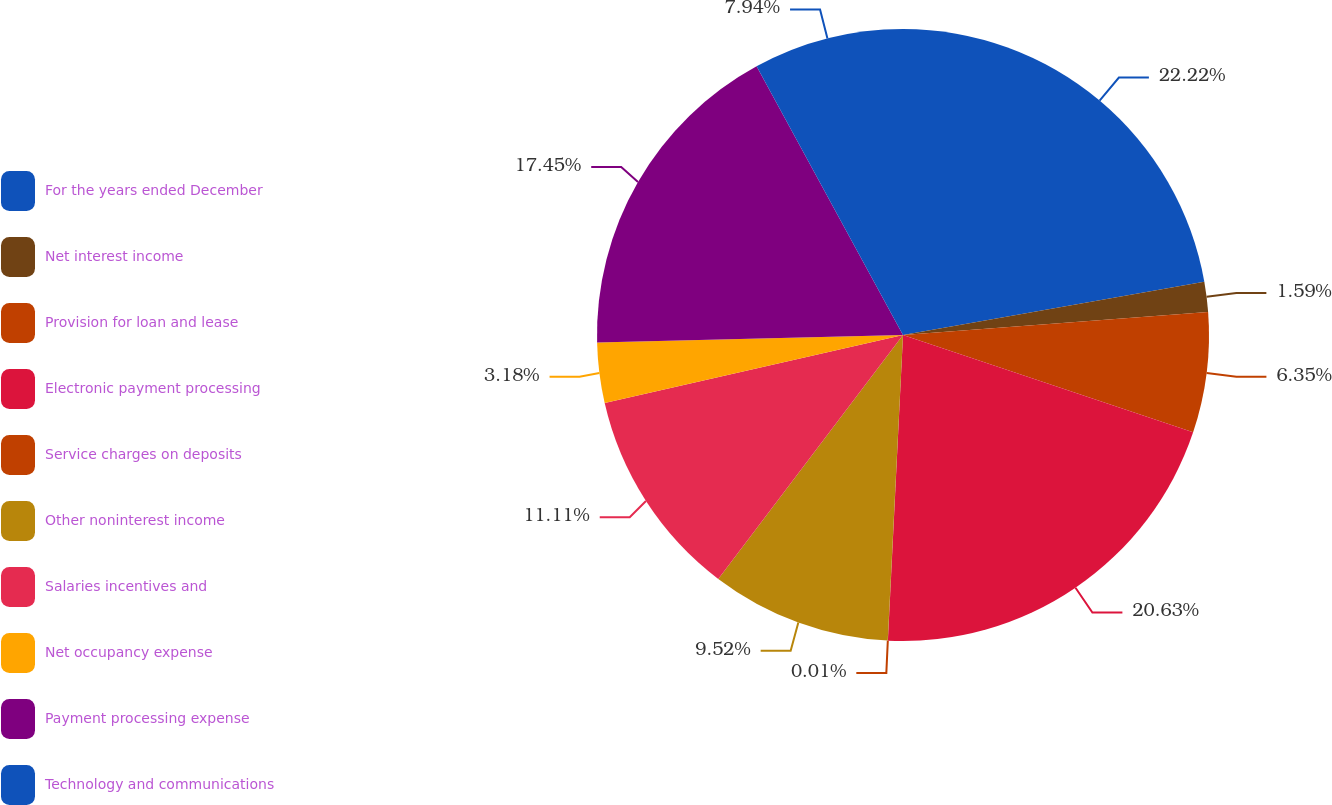Convert chart to OTSL. <chart><loc_0><loc_0><loc_500><loc_500><pie_chart><fcel>For the years ended December<fcel>Net interest income<fcel>Provision for loan and lease<fcel>Electronic payment processing<fcel>Service charges on deposits<fcel>Other noninterest income<fcel>Salaries incentives and<fcel>Net occupancy expense<fcel>Payment processing expense<fcel>Technology and communications<nl><fcel>22.21%<fcel>1.59%<fcel>6.35%<fcel>20.63%<fcel>0.01%<fcel>9.52%<fcel>11.11%<fcel>3.18%<fcel>17.45%<fcel>7.94%<nl></chart> 